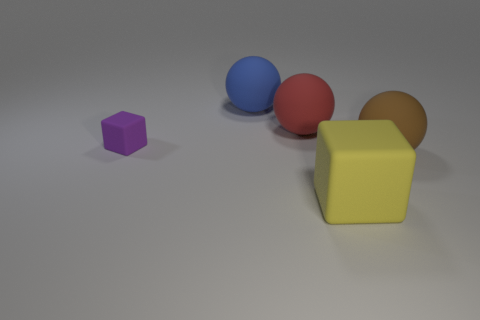What number of small things are either blue spheres or yellow matte objects?
Offer a terse response. 0. There is a matte block in front of the tiny object; is it the same color as the cube behind the big cube?
Ensure brevity in your answer.  No. Is there a large red thing made of the same material as the big brown sphere?
Provide a succinct answer. Yes. How many blue things are small rubber objects or spheres?
Give a very brief answer. 1. Is the number of matte balls in front of the large blue sphere greater than the number of small purple matte blocks?
Your response must be concise. Yes. Do the yellow object and the purple cube have the same size?
Your answer should be compact. No. There is a small cube that is made of the same material as the red sphere; what color is it?
Your response must be concise. Purple. Are there the same number of large balls that are on the right side of the large yellow cube and big red matte balls that are on the left side of the red rubber ball?
Make the answer very short. No. There is a object in front of the matte sphere in front of the small purple matte block; what shape is it?
Make the answer very short. Cube. There is a block that is the same size as the red matte thing; what color is it?
Provide a succinct answer. Yellow. 